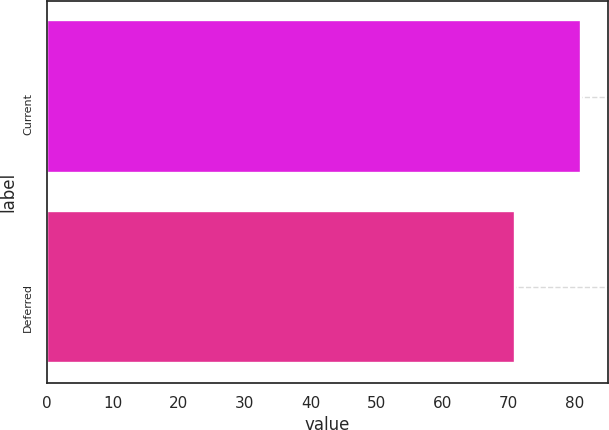<chart> <loc_0><loc_0><loc_500><loc_500><bar_chart><fcel>Current<fcel>Deferred<nl><fcel>81<fcel>71<nl></chart> 